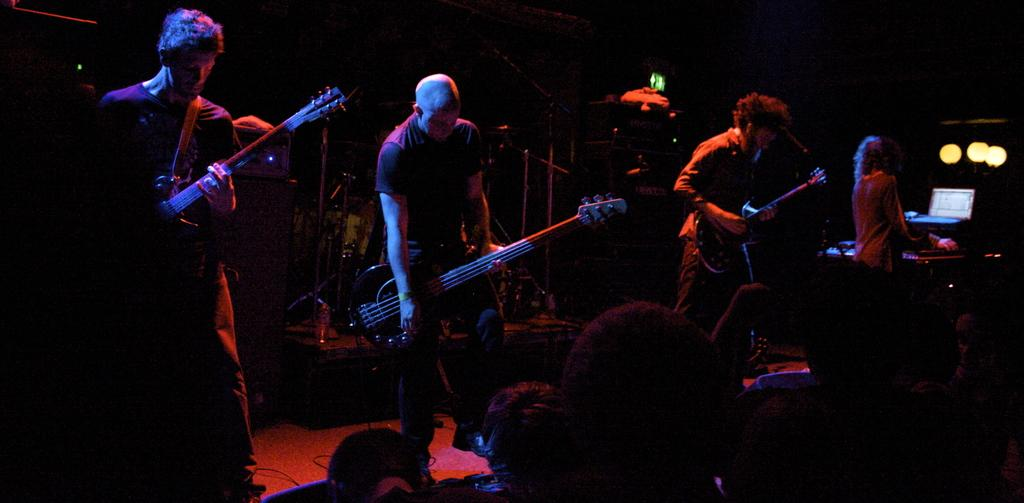What is the main activity being performed by the group of people in the image? The group of people are playing a guitar in the image. Can you describe the woman's role in the image? The woman is playing a piano in the image. What can be seen in the background or surrounding the people in the image? There is a light visible in the image. What type of lettuce is being used as a prop in the image? There is no lettuce present in the image. How does the love between the musicians affect the quality of their performance in the image? The image does not provide any information about the musicians' feelings or emotions, so it is impossible to determine how love might affect their performance. 